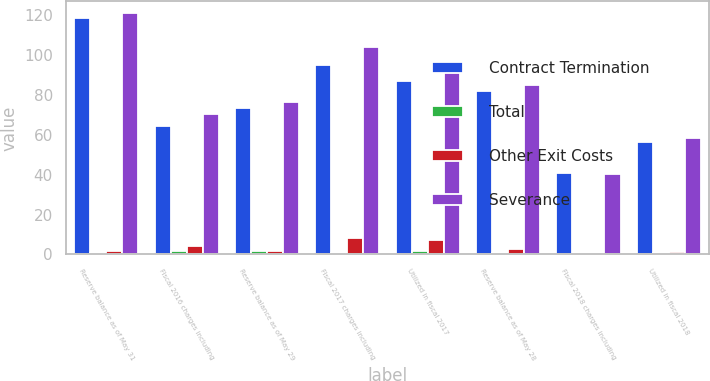Convert chart. <chart><loc_0><loc_0><loc_500><loc_500><stacked_bar_chart><ecel><fcel>Reserve balance as of May 31<fcel>Fiscal 2016 charges including<fcel>Reserve balance as of May 29<fcel>Fiscal 2017 charges including<fcel>Utilized in fiscal 2017<fcel>Reserve balance as of May 28<fcel>Fiscal 2018 charges including<fcel>Utilized in fiscal 2018<nl><fcel>Contract Termination<fcel>118.6<fcel>64.3<fcel>73.6<fcel>95<fcel>86.8<fcel>81.8<fcel>40.8<fcel>56.6<nl><fcel>Total<fcel>0.6<fcel>1.6<fcel>1.5<fcel>0.9<fcel>1.7<fcel>0.7<fcel>0.2<fcel>0.8<nl><fcel>Other Exit Costs<fcel>1.6<fcel>4.3<fcel>1.5<fcel>8.1<fcel>7.1<fcel>2.5<fcel>0.7<fcel>1.1<nl><fcel>Severance<fcel>120.8<fcel>70.2<fcel>76.6<fcel>104<fcel>95.6<fcel>85<fcel>40.3<fcel>58.5<nl></chart> 